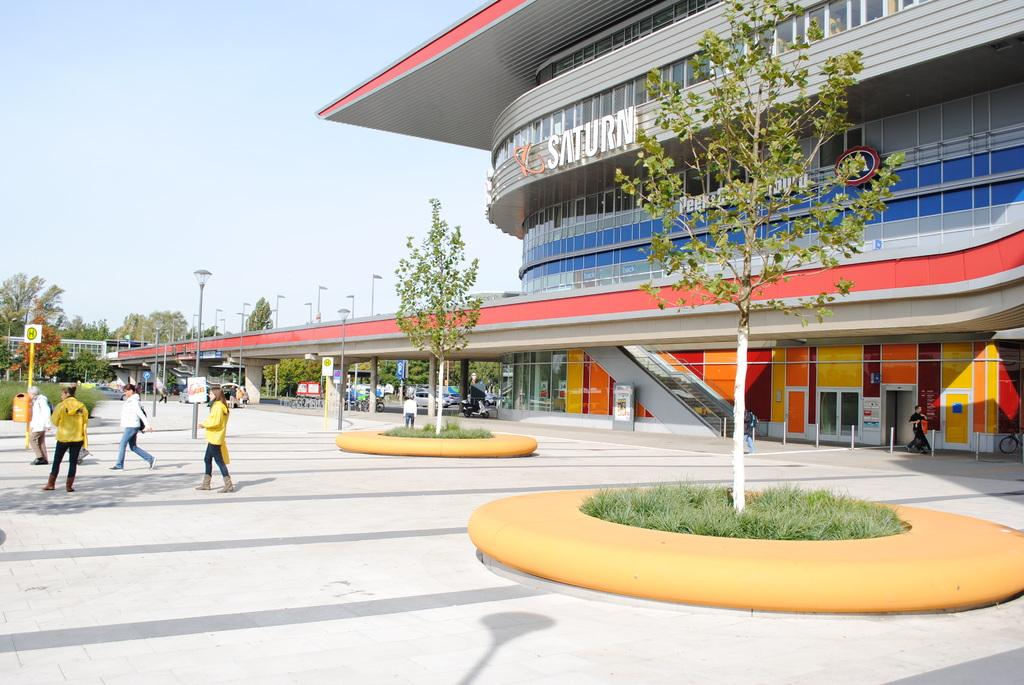Provide a one-sentence caption for the provided image. an exterior of the Saturn building with trees in yellow circles. 